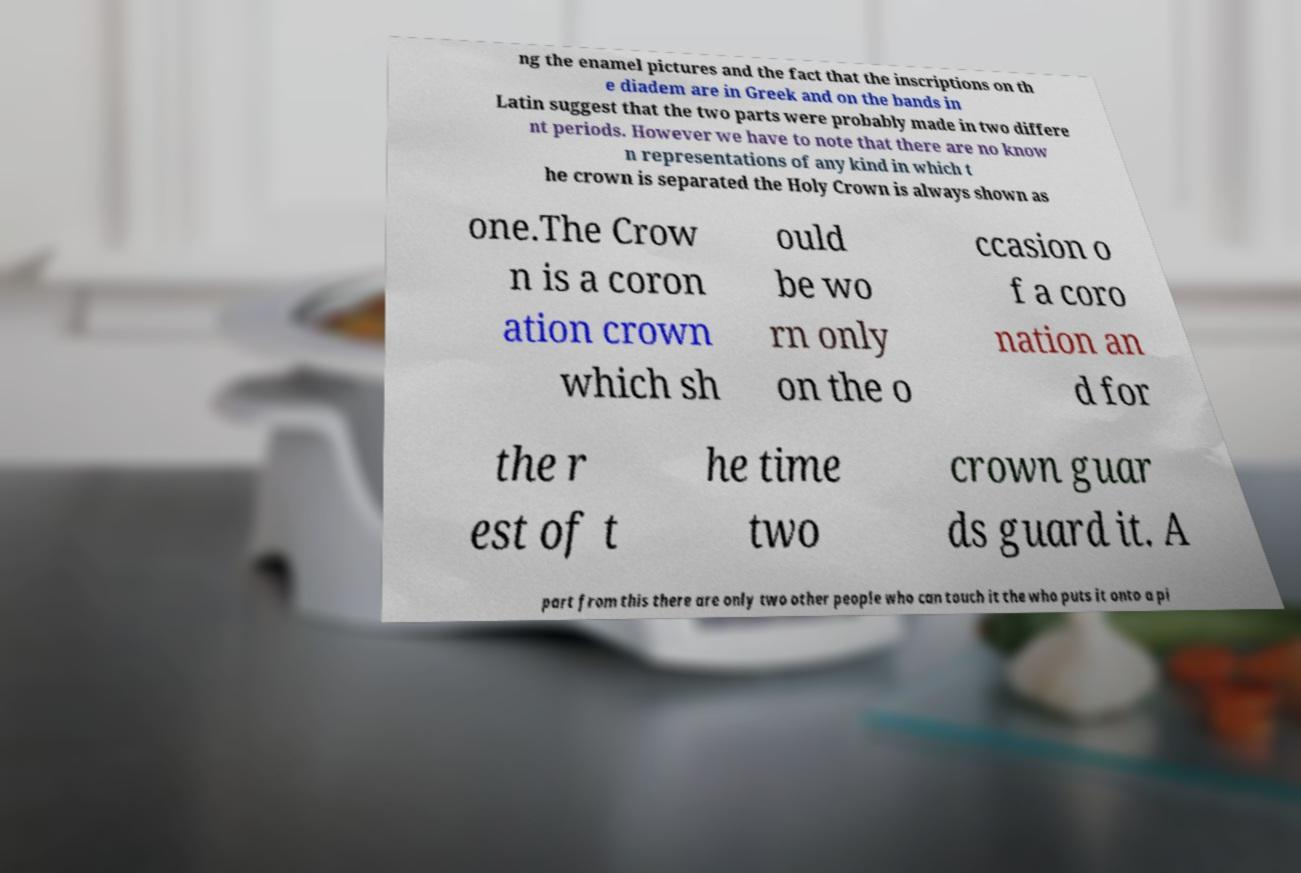Could you extract and type out the text from this image? ng the enamel pictures and the fact that the inscriptions on th e diadem are in Greek and on the bands in Latin suggest that the two parts were probably made in two differe nt periods. However we have to note that there are no know n representations of any kind in which t he crown is separated the Holy Crown is always shown as one.The Crow n is a coron ation crown which sh ould be wo rn only on the o ccasion o f a coro nation an d for the r est of t he time two crown guar ds guard it. A part from this there are only two other people who can touch it the who puts it onto a pi 